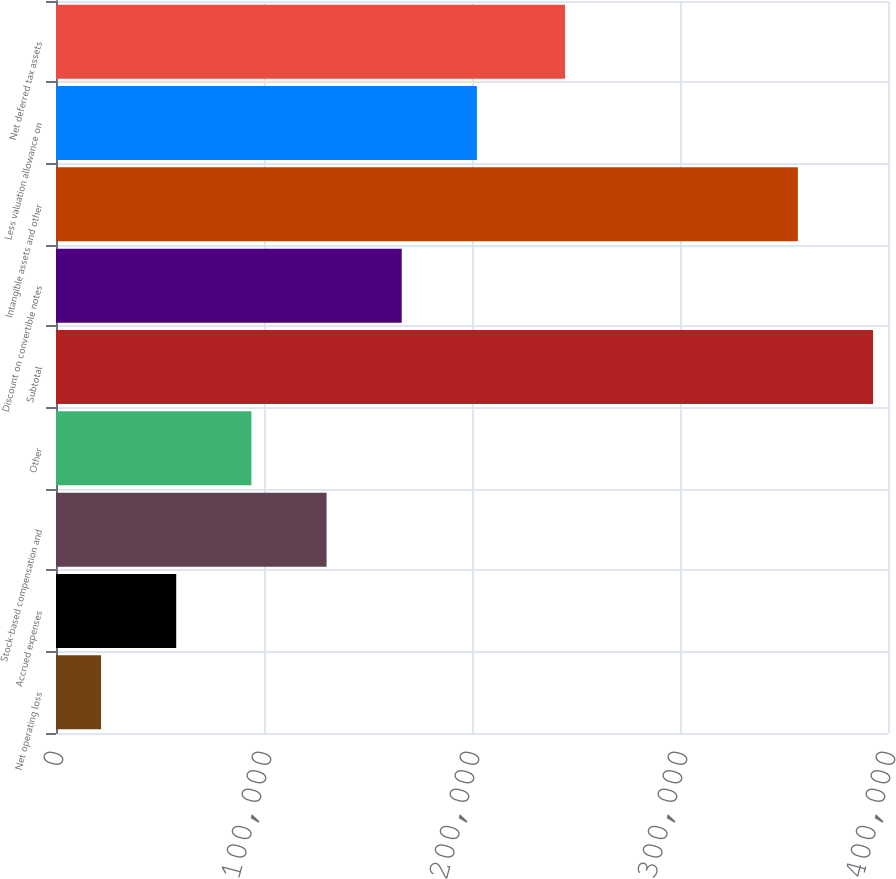Convert chart. <chart><loc_0><loc_0><loc_500><loc_500><bar_chart><fcel>Net operating loss<fcel>Accrued expenses<fcel>Stock-based compensation and<fcel>Other<fcel>Subtotal<fcel>Discount on convertible notes<fcel>Intangible assets and other<fcel>Less valuation allowance on<fcel>Net deferred tax assets<nl><fcel>21660<fcel>57799.6<fcel>130079<fcel>93939.2<fcel>392809<fcel>166218<fcel>356669<fcel>202358<fcel>244721<nl></chart> 